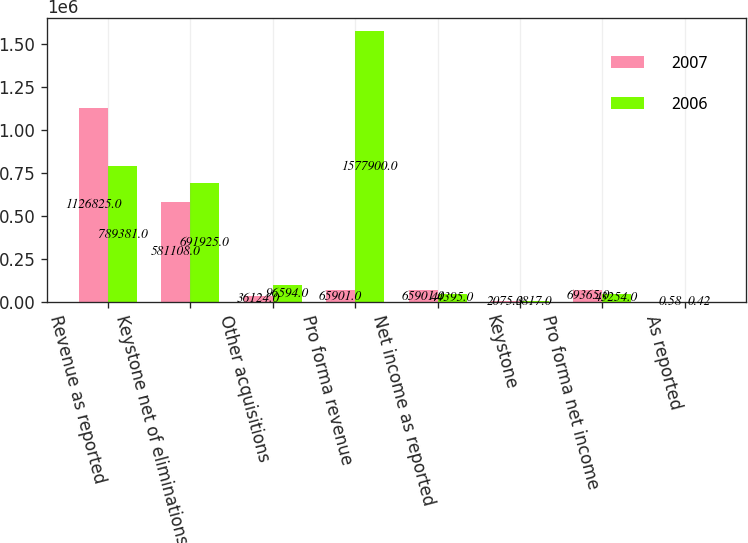Convert chart. <chart><loc_0><loc_0><loc_500><loc_500><stacked_bar_chart><ecel><fcel>Revenue as reported<fcel>Keystone net of eliminations<fcel>Other acquisitions<fcel>Pro forma revenue<fcel>Net income as reported<fcel>Keystone<fcel>Pro forma net income<fcel>As reported<nl><fcel>2007<fcel>1.12682e+06<fcel>581108<fcel>36124<fcel>65901<fcel>65901<fcel>2075<fcel>69365<fcel>0.58<nl><fcel>2006<fcel>789381<fcel>691925<fcel>96594<fcel>1.5779e+06<fcel>44395<fcel>3817<fcel>43254<fcel>0.42<nl></chart> 